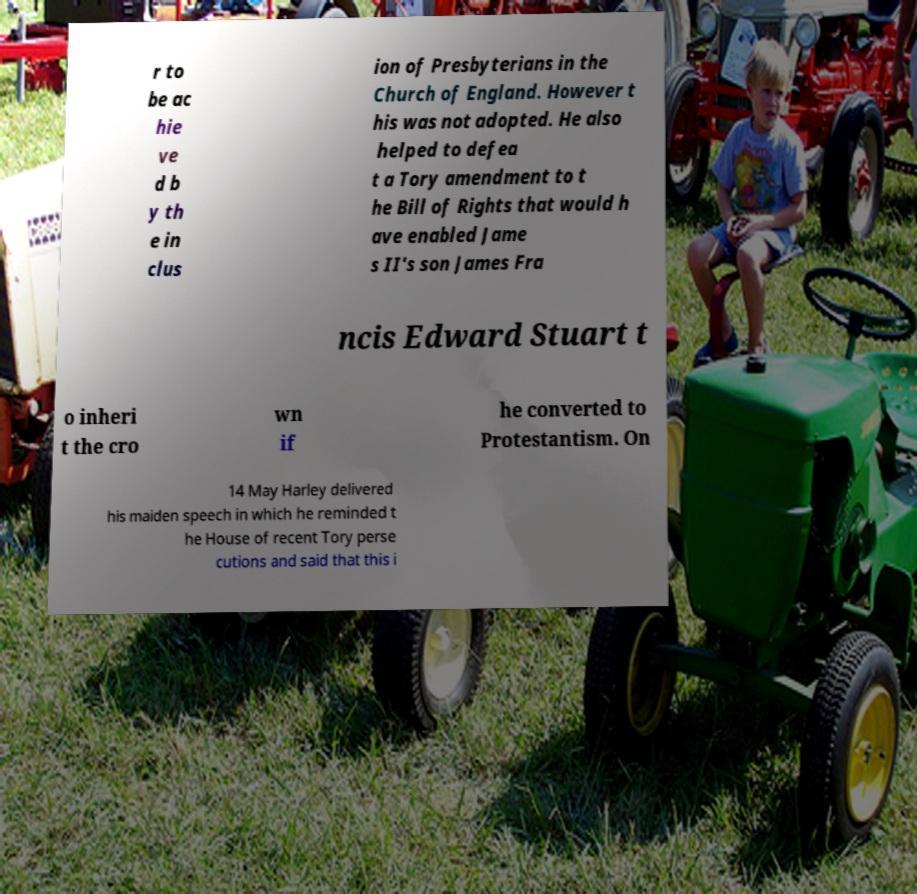For documentation purposes, I need the text within this image transcribed. Could you provide that? r to be ac hie ve d b y th e in clus ion of Presbyterians in the Church of England. However t his was not adopted. He also helped to defea t a Tory amendment to t he Bill of Rights that would h ave enabled Jame s II's son James Fra ncis Edward Stuart t o inheri t the cro wn if he converted to Protestantism. On 14 May Harley delivered his maiden speech in which he reminded t he House of recent Tory perse cutions and said that this i 